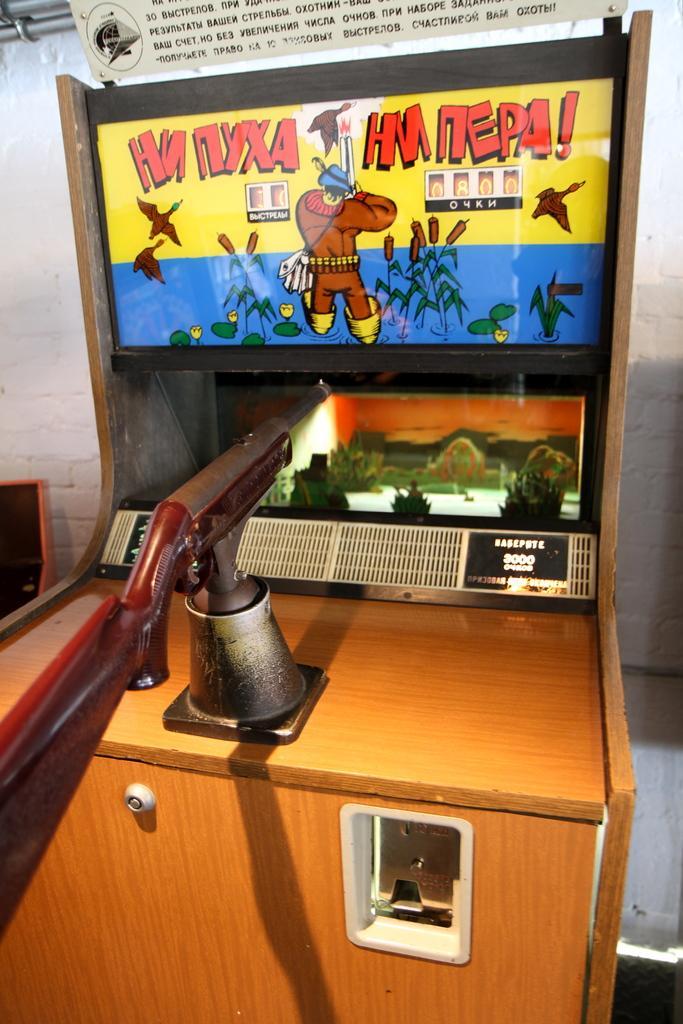Could you give a brief overview of what you see in this image? This picture is taken inside the room. In this image, in the middle, we can see a table, on the table, we can see metal instrument. In the background of the table, we can see an LCD display. At the top of the table, we can see a paper attached to it, on the paper, we can see some pictures and text written on it. At the top, we can see some text written on the paper and a wall. 